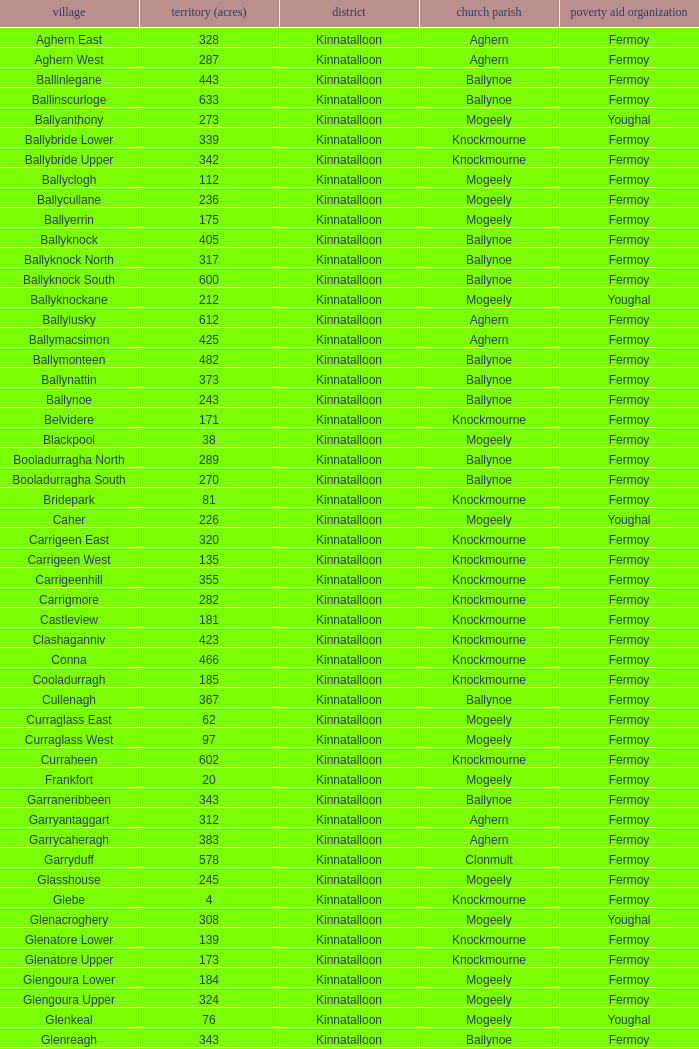Write the full table. {'header': ['village', 'territory (acres)', 'district', 'church parish', 'poverty aid organization'], 'rows': [['Aghern East', '328', 'Kinnatalloon', 'Aghern', 'Fermoy'], ['Aghern West', '287', 'Kinnatalloon', 'Aghern', 'Fermoy'], ['Ballinlegane', '443', 'Kinnatalloon', 'Ballynoe', 'Fermoy'], ['Ballinscurloge', '633', 'Kinnatalloon', 'Ballynoe', 'Fermoy'], ['Ballyanthony', '273', 'Kinnatalloon', 'Mogeely', 'Youghal'], ['Ballybride Lower', '339', 'Kinnatalloon', 'Knockmourne', 'Fermoy'], ['Ballybride Upper', '342', 'Kinnatalloon', 'Knockmourne', 'Fermoy'], ['Ballyclogh', '112', 'Kinnatalloon', 'Mogeely', 'Fermoy'], ['Ballycullane', '236', 'Kinnatalloon', 'Mogeely', 'Fermoy'], ['Ballyerrin', '175', 'Kinnatalloon', 'Mogeely', 'Fermoy'], ['Ballyknock', '405', 'Kinnatalloon', 'Ballynoe', 'Fermoy'], ['Ballyknock North', '317', 'Kinnatalloon', 'Ballynoe', 'Fermoy'], ['Ballyknock South', '600', 'Kinnatalloon', 'Ballynoe', 'Fermoy'], ['Ballyknockane', '212', 'Kinnatalloon', 'Mogeely', 'Youghal'], ['Ballylusky', '612', 'Kinnatalloon', 'Aghern', 'Fermoy'], ['Ballymacsimon', '425', 'Kinnatalloon', 'Aghern', 'Fermoy'], ['Ballymonteen', '482', 'Kinnatalloon', 'Ballynoe', 'Fermoy'], ['Ballynattin', '373', 'Kinnatalloon', 'Ballynoe', 'Fermoy'], ['Ballynoe', '243', 'Kinnatalloon', 'Ballynoe', 'Fermoy'], ['Belvidere', '171', 'Kinnatalloon', 'Knockmourne', 'Fermoy'], ['Blackpool', '38', 'Kinnatalloon', 'Mogeely', 'Fermoy'], ['Booladurragha North', '289', 'Kinnatalloon', 'Ballynoe', 'Fermoy'], ['Booladurragha South', '270', 'Kinnatalloon', 'Ballynoe', 'Fermoy'], ['Bridepark', '81', 'Kinnatalloon', 'Knockmourne', 'Fermoy'], ['Caher', '226', 'Kinnatalloon', 'Mogeely', 'Youghal'], ['Carrigeen East', '320', 'Kinnatalloon', 'Knockmourne', 'Fermoy'], ['Carrigeen West', '135', 'Kinnatalloon', 'Knockmourne', 'Fermoy'], ['Carrigeenhill', '355', 'Kinnatalloon', 'Knockmourne', 'Fermoy'], ['Carrigmore', '282', 'Kinnatalloon', 'Knockmourne', 'Fermoy'], ['Castleview', '181', 'Kinnatalloon', 'Knockmourne', 'Fermoy'], ['Clashaganniv', '423', 'Kinnatalloon', 'Knockmourne', 'Fermoy'], ['Conna', '466', 'Kinnatalloon', 'Knockmourne', 'Fermoy'], ['Cooladurragh', '185', 'Kinnatalloon', 'Knockmourne', 'Fermoy'], ['Cullenagh', '367', 'Kinnatalloon', 'Ballynoe', 'Fermoy'], ['Curraglass East', '62', 'Kinnatalloon', 'Mogeely', 'Fermoy'], ['Curraglass West', '97', 'Kinnatalloon', 'Mogeely', 'Fermoy'], ['Curraheen', '602', 'Kinnatalloon', 'Knockmourne', 'Fermoy'], ['Frankfort', '20', 'Kinnatalloon', 'Mogeely', 'Fermoy'], ['Garraneribbeen', '343', 'Kinnatalloon', 'Ballynoe', 'Fermoy'], ['Garryantaggart', '312', 'Kinnatalloon', 'Aghern', 'Fermoy'], ['Garrycaheragh', '383', 'Kinnatalloon', 'Aghern', 'Fermoy'], ['Garryduff', '578', 'Kinnatalloon', 'Clonmult', 'Fermoy'], ['Glasshouse', '245', 'Kinnatalloon', 'Mogeely', 'Fermoy'], ['Glebe', '4', 'Kinnatalloon', 'Knockmourne', 'Fermoy'], ['Glenacroghery', '308', 'Kinnatalloon', 'Mogeely', 'Youghal'], ['Glenatore Lower', '139', 'Kinnatalloon', 'Knockmourne', 'Fermoy'], ['Glenatore Upper', '173', 'Kinnatalloon', 'Knockmourne', 'Fermoy'], ['Glengoura Lower', '184', 'Kinnatalloon', 'Mogeely', 'Fermoy'], ['Glengoura Upper', '324', 'Kinnatalloon', 'Mogeely', 'Fermoy'], ['Glenkeal', '76', 'Kinnatalloon', 'Mogeely', 'Youghal'], ['Glenreagh', '343', 'Kinnatalloon', 'Ballynoe', 'Fermoy'], ['Glentane', '274', 'Kinnatalloon', 'Ballynoe', 'Fermoy'], ['Glentrasna', '284', 'Kinnatalloon', 'Aghern', 'Fermoy'], ['Glentrasna North', '219', 'Kinnatalloon', 'Aghern', 'Fermoy'], ['Glentrasna South', '220', 'Kinnatalloon', 'Aghern', 'Fermoy'], ['Gortnafira', '78', 'Kinnatalloon', 'Mogeely', 'Fermoy'], ['Inchyallagh', '8', 'Kinnatalloon', 'Mogeely', 'Fermoy'], ['Kilclare Lower', '109', 'Kinnatalloon', 'Knockmourne', 'Fermoy'], ['Kilclare Upper', '493', 'Kinnatalloon', 'Knockmourne', 'Fermoy'], ['Kilcronat', '516', 'Kinnatalloon', 'Mogeely', 'Youghal'], ['Kilcronatmountain', '385', 'Kinnatalloon', 'Mogeely', 'Youghal'], ['Killasseragh', '340', 'Kinnatalloon', 'Ballynoe', 'Fermoy'], ['Killavarilly', '372', 'Kinnatalloon', 'Knockmourne', 'Fermoy'], ['Kilmacow', '316', 'Kinnatalloon', 'Mogeely', 'Fermoy'], ['Kilnafurrery', '256', 'Kinnatalloon', 'Mogeely', 'Youghal'], ['Kilphillibeen', '535', 'Kinnatalloon', 'Ballynoe', 'Fermoy'], ['Knockacool', '404', 'Kinnatalloon', 'Mogeely', 'Youghal'], ['Knockakeo', '296', 'Kinnatalloon', 'Ballynoe', 'Fermoy'], ['Knockanarrig', '215', 'Kinnatalloon', 'Mogeely', 'Youghal'], ['Knockastickane', '164', 'Kinnatalloon', 'Knockmourne', 'Fermoy'], ['Knocknagapple', '293', 'Kinnatalloon', 'Aghern', 'Fermoy'], ['Lackbrack', '84', 'Kinnatalloon', 'Mogeely', 'Fermoy'], ['Lacken', '262', 'Kinnatalloon', 'Mogeely', 'Youghal'], ['Lackenbehy', '101', 'Kinnatalloon', 'Mogeely', 'Fermoy'], ['Limekilnclose', '41', 'Kinnatalloon', 'Mogeely', 'Lismore'], ['Lisnabrin Lower', '114', 'Kinnatalloon', 'Mogeely', 'Fermoy'], ['Lisnabrin North', '217', 'Kinnatalloon', 'Mogeely', 'Fermoy'], ['Lisnabrin South', '180', 'Kinnatalloon', 'Mogeely', 'Fermoy'], ['Lisnabrinlodge', '28', 'Kinnatalloon', 'Mogeely', 'Fermoy'], ['Littlegrace', '50', 'Kinnatalloon', 'Knockmourne', 'Lismore'], ['Longueville North', '355', 'Kinnatalloon', 'Ballynoe', 'Fermoy'], ['Longueville South', '271', 'Kinnatalloon', 'Ballynoe', 'Fermoy'], ['Lyre', '160', 'Kinnatalloon', 'Mogeely', 'Youghal'], ['Lyre Mountain', '360', 'Kinnatalloon', 'Mogeely', 'Youghal'], ['Mogeely Lower', '304', 'Kinnatalloon', 'Mogeely', 'Fermoy'], ['Mogeely Upper', '247', 'Kinnatalloon', 'Mogeely', 'Fermoy'], ['Monagown', '491', 'Kinnatalloon', 'Knockmourne', 'Fermoy'], ['Monaloo', '458', 'Kinnatalloon', 'Mogeely', 'Youghal'], ['Mountprospect', '102', 'Kinnatalloon', 'Mogeely', 'Fermoy'], ['Park', '119', 'Kinnatalloon', 'Aghern', 'Fermoy'], ['Poundfields', '15', 'Kinnatalloon', 'Mogeely', 'Fermoy'], ['Rathdrum', '336', 'Kinnatalloon', 'Ballynoe', 'Fermoy'], ['Rathdrum', '339', 'Kinnatalloon', 'Britway', 'Fermoy'], ['Reanduff', '318', 'Kinnatalloon', 'Mogeely', 'Youghal'], ['Rearour North', '208', 'Kinnatalloon', 'Mogeely', 'Youghal'], ['Rearour South', '223', 'Kinnatalloon', 'Mogeely', 'Youghal'], ['Rosybower', '105', 'Kinnatalloon', 'Mogeely', 'Fermoy'], ['Sandyhill', '263', 'Kinnatalloon', 'Mogeely', 'Youghal'], ['Shanaboola', '190', 'Kinnatalloon', 'Ballynoe', 'Fermoy'], ['Shanakill Lower', '244', 'Kinnatalloon', 'Mogeely', 'Fermoy'], ['Shanakill Upper', '244', 'Kinnatalloon', 'Mogeely', 'Fermoy'], ['Slieveadoctor', '260', 'Kinnatalloon', 'Mogeely', 'Fermoy'], ['Templevally', '330', 'Kinnatalloon', 'Mogeely', 'Fermoy'], ['Vinepark', '7', 'Kinnatalloon', 'Mogeely', 'Fermoy']]} Name the civil parish for garryduff Clonmult. 